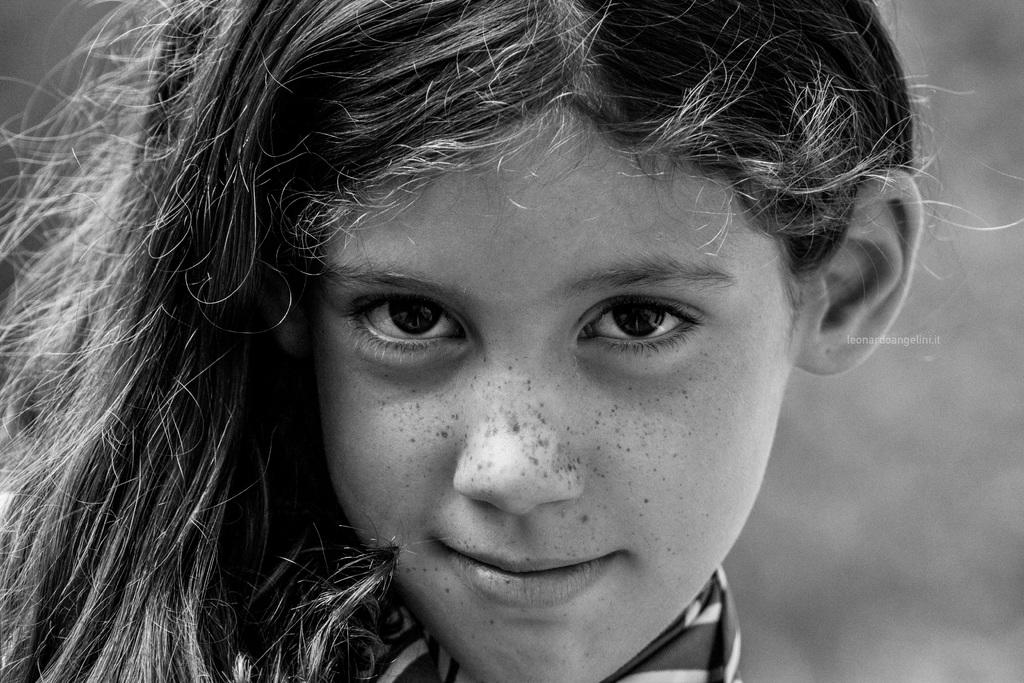What is the color scheme of the image? The image is black and white. Can you describe the main subject of the image? There is a girl in the image. What type of comfort can be seen in the image? There is no specific type of comfort visible in the image, as it is a black and white image of a girl. 